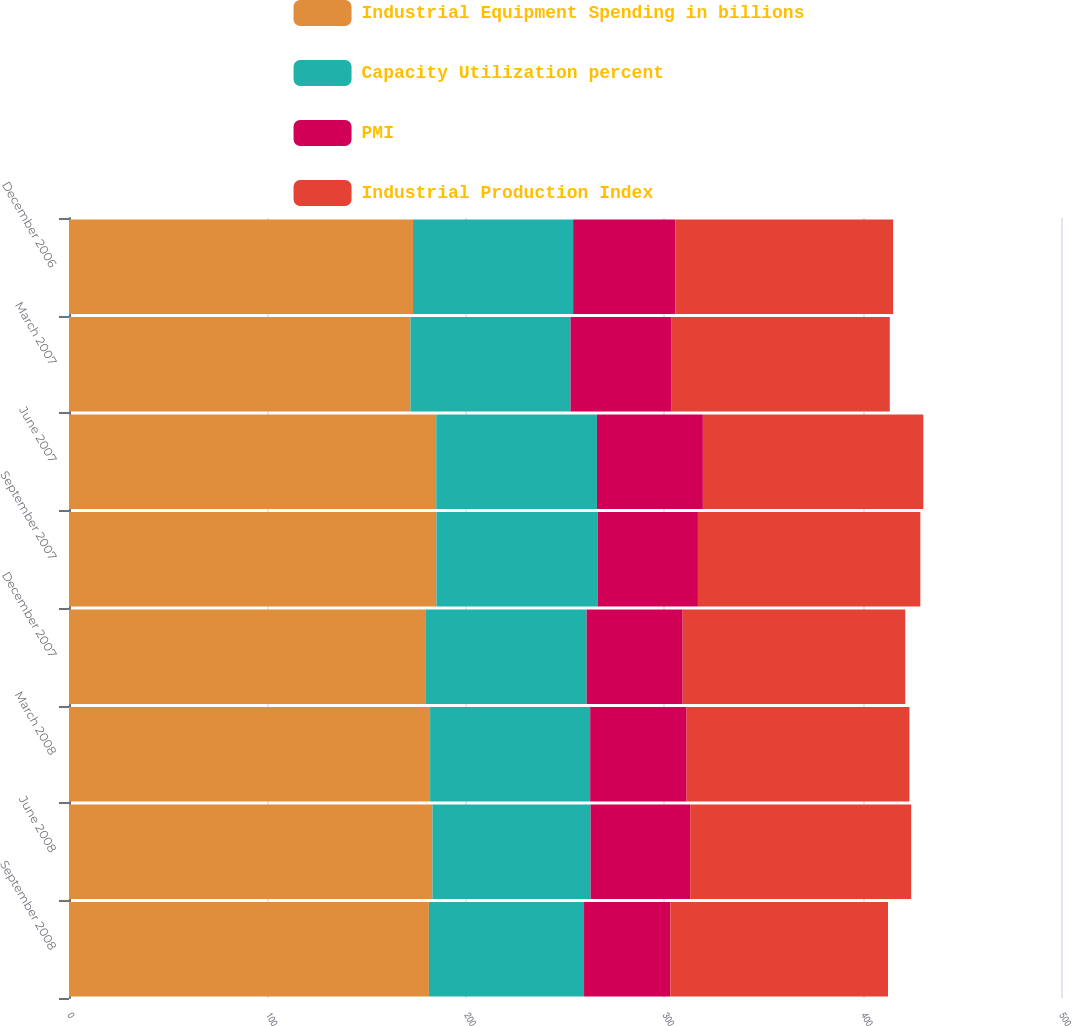Convert chart to OTSL. <chart><loc_0><loc_0><loc_500><loc_500><stacked_bar_chart><ecel><fcel>September 2008<fcel>June 2008<fcel>March 2008<fcel>December 2007<fcel>September 2007<fcel>June 2007<fcel>March 2007<fcel>December 2006<nl><fcel>Industrial Equipment Spending in billions<fcel>181.4<fcel>183.2<fcel>182<fcel>179.9<fcel>185.2<fcel>185.1<fcel>172.1<fcel>173.4<nl><fcel>Capacity Utilization percent<fcel>78.2<fcel>79.7<fcel>80.7<fcel>81<fcel>81.3<fcel>81<fcel>80.7<fcel>80.7<nl><fcel>PMI<fcel>43.5<fcel>50.2<fcel>48.6<fcel>48.4<fcel>50.5<fcel>53.4<fcel>50.7<fcel>51.5<nl><fcel>Industrial Production Index<fcel>109.7<fcel>111.4<fcel>112.3<fcel>112.2<fcel>112.1<fcel>111.1<fcel>110.2<fcel>109.8<nl></chart> 